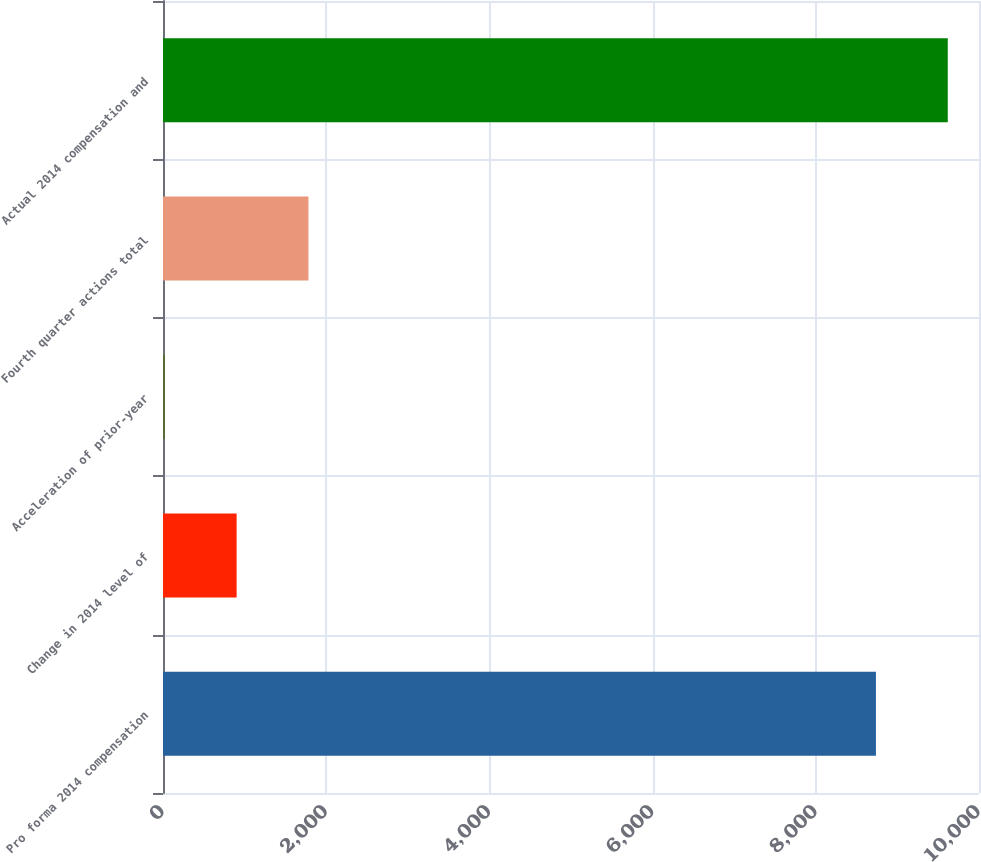Convert chart. <chart><loc_0><loc_0><loc_500><loc_500><bar_chart><fcel>Pro forma 2014 compensation<fcel>Change in 2014 level of<fcel>Acceleration of prior-year<fcel>Fourth quarter actions total<fcel>Actual 2014 compensation and<nl><fcel>8737<fcel>902.3<fcel>22<fcel>1782.6<fcel>9617.3<nl></chart> 